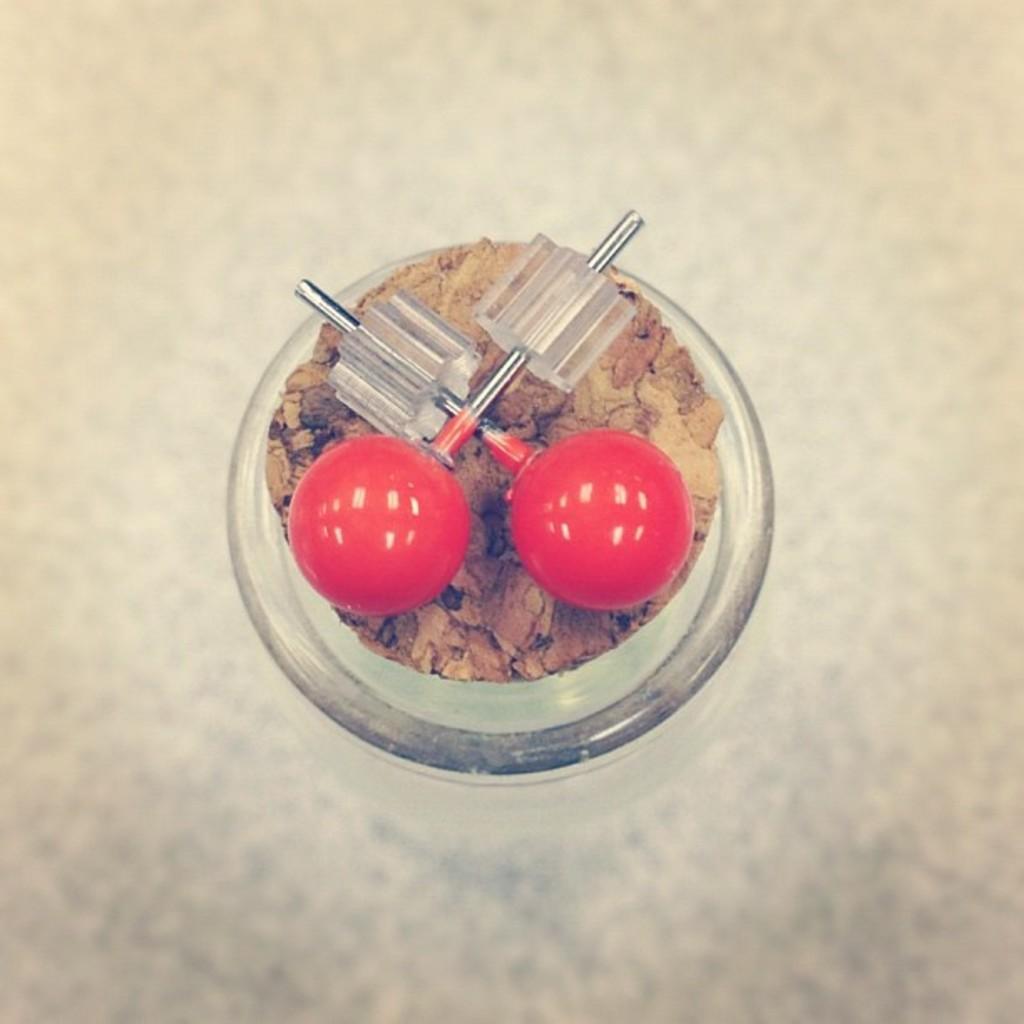How would you summarize this image in a sentence or two? In this image I can see there are red colored balls on a glass jar. 